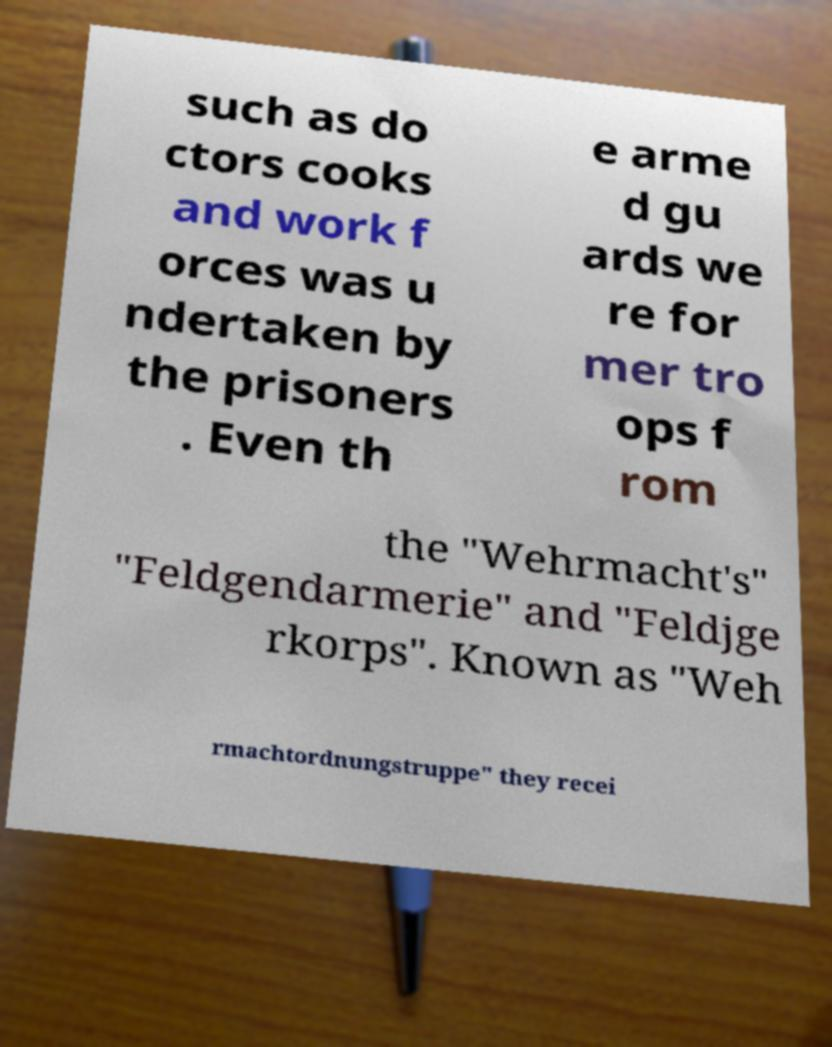Can you accurately transcribe the text from the provided image for me? such as do ctors cooks and work f orces was u ndertaken by the prisoners . Even th e arme d gu ards we re for mer tro ops f rom the "Wehrmacht's" "Feldgendarmerie" and "Feldjge rkorps". Known as "Weh rmachtordnungstruppe" they recei 